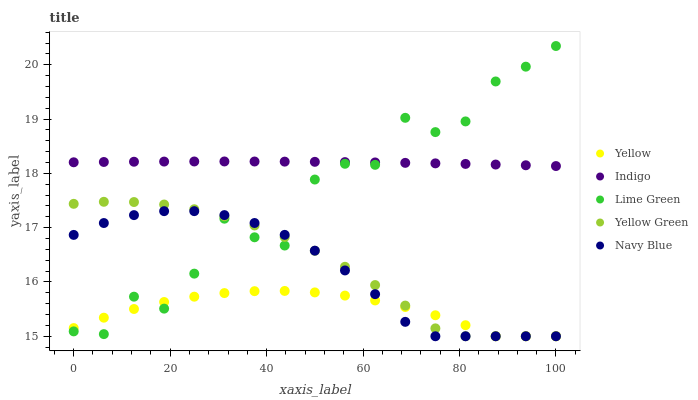Does Yellow have the minimum area under the curve?
Answer yes or no. Yes. Does Indigo have the maximum area under the curve?
Answer yes or no. Yes. Does Yellow Green have the minimum area under the curve?
Answer yes or no. No. Does Yellow Green have the maximum area under the curve?
Answer yes or no. No. Is Indigo the smoothest?
Answer yes or no. Yes. Is Lime Green the roughest?
Answer yes or no. Yes. Is Yellow Green the smoothest?
Answer yes or no. No. Is Yellow Green the roughest?
Answer yes or no. No. Does Yellow Green have the lowest value?
Answer yes or no. Yes. Does Indigo have the lowest value?
Answer yes or no. No. Does Lime Green have the highest value?
Answer yes or no. Yes. Does Indigo have the highest value?
Answer yes or no. No. Is Yellow Green less than Indigo?
Answer yes or no. Yes. Is Indigo greater than Yellow Green?
Answer yes or no. Yes. Does Yellow Green intersect Navy Blue?
Answer yes or no. Yes. Is Yellow Green less than Navy Blue?
Answer yes or no. No. Is Yellow Green greater than Navy Blue?
Answer yes or no. No. Does Yellow Green intersect Indigo?
Answer yes or no. No. 